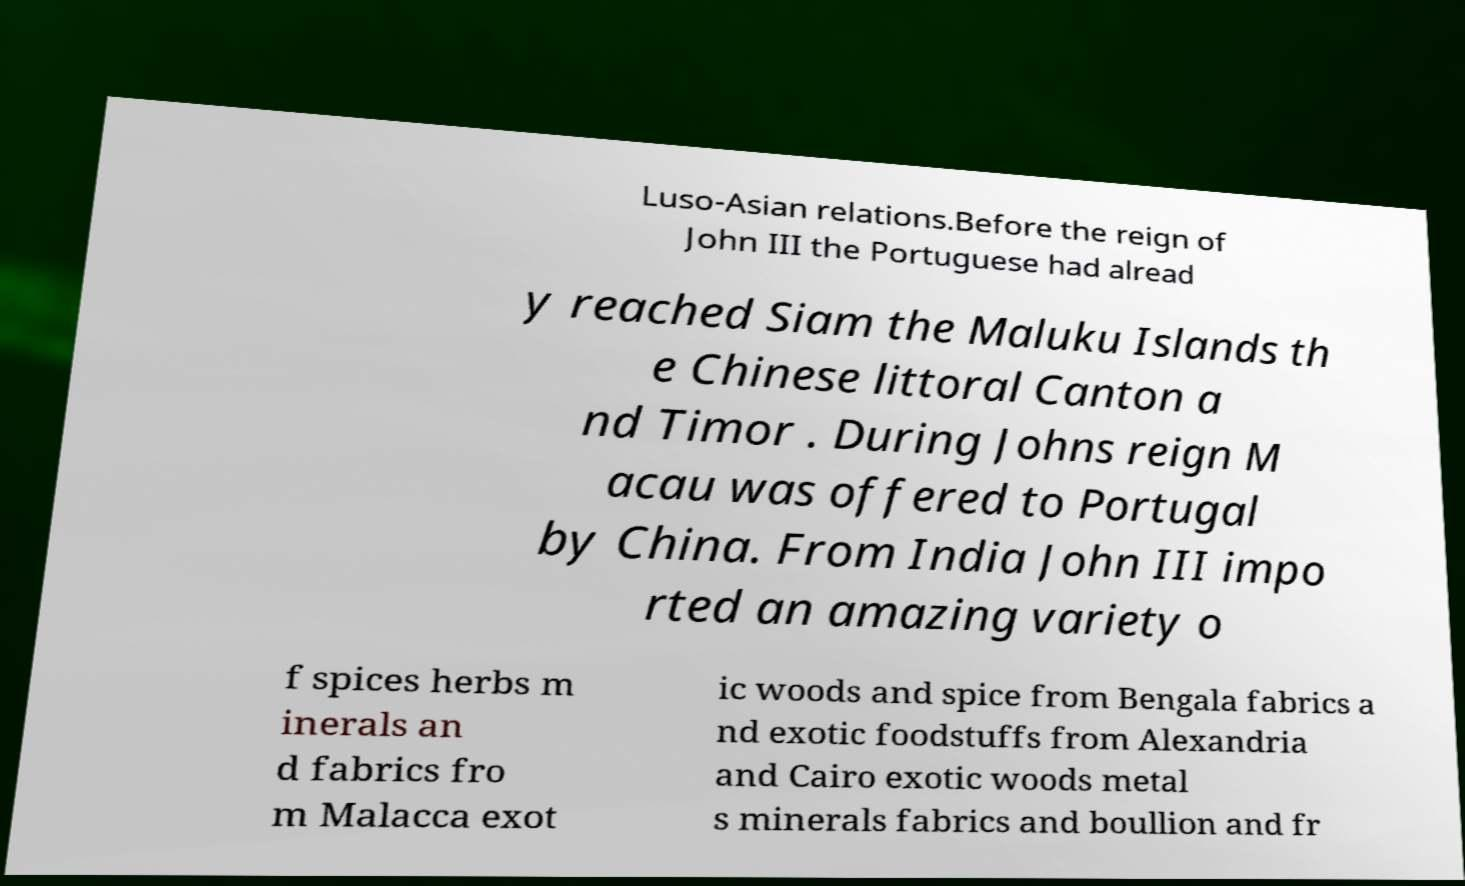Please identify and transcribe the text found in this image. Luso-Asian relations.Before the reign of John III the Portuguese had alread y reached Siam the Maluku Islands th e Chinese littoral Canton a nd Timor . During Johns reign M acau was offered to Portugal by China. From India John III impo rted an amazing variety o f spices herbs m inerals an d fabrics fro m Malacca exot ic woods and spice from Bengala fabrics a nd exotic foodstuffs from Alexandria and Cairo exotic woods metal s minerals fabrics and boullion and fr 